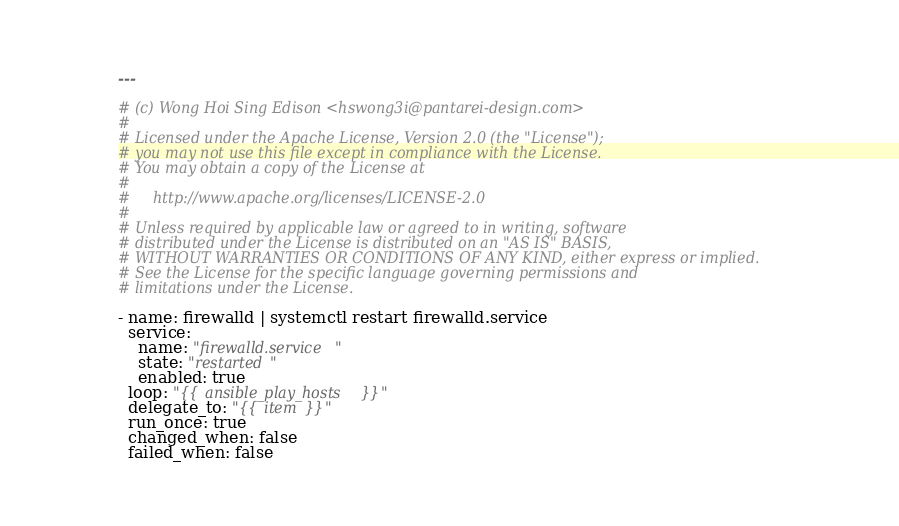<code> <loc_0><loc_0><loc_500><loc_500><_YAML_>---

# (c) Wong Hoi Sing Edison <hswong3i@pantarei-design.com>
#
# Licensed under the Apache License, Version 2.0 (the "License");
# you may not use this file except in compliance with the License.
# You may obtain a copy of the License at
#
#     http://www.apache.org/licenses/LICENSE-2.0
#
# Unless required by applicable law or agreed to in writing, software
# distributed under the License is distributed on an "AS IS" BASIS,
# WITHOUT WARRANTIES OR CONDITIONS OF ANY KIND, either express or implied.
# See the License for the specific language governing permissions and
# limitations under the License.

- name: firewalld | systemctl restart firewalld.service
  service:
    name: "firewalld.service"
    state: "restarted"
    enabled: true
  loop: "{{ ansible_play_hosts }}"
  delegate_to: "{{ item }}"
  run_once: true
  changed_when: false
  failed_when: false
</code> 